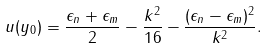Convert formula to latex. <formula><loc_0><loc_0><loc_500><loc_500>u ( y _ { 0 } ) = \frac { \epsilon _ { n } + \epsilon _ { m } } { 2 } - \frac { k ^ { 2 } } { 1 6 } - \frac { ( \epsilon _ { n } - \epsilon _ { m } ) ^ { 2 } } { k ^ { 2 } } .</formula> 